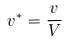<formula> <loc_0><loc_0><loc_500><loc_500>v ^ { * } = \frac { v } { V }</formula> 